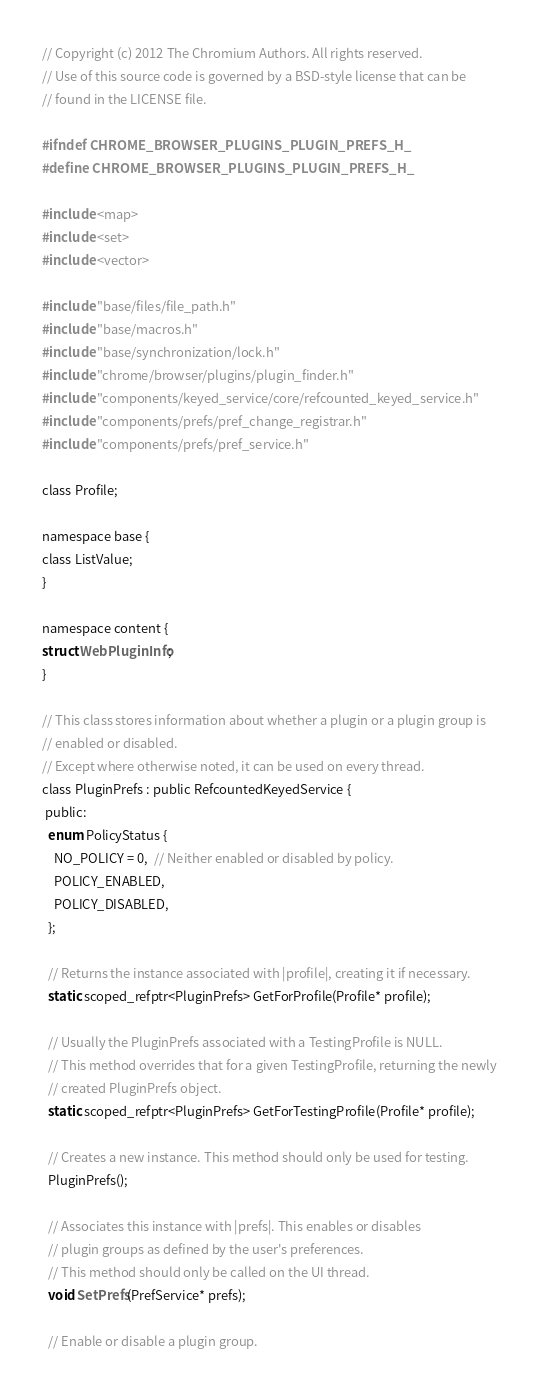<code> <loc_0><loc_0><loc_500><loc_500><_C_>// Copyright (c) 2012 The Chromium Authors. All rights reserved.
// Use of this source code is governed by a BSD-style license that can be
// found in the LICENSE file.

#ifndef CHROME_BROWSER_PLUGINS_PLUGIN_PREFS_H_
#define CHROME_BROWSER_PLUGINS_PLUGIN_PREFS_H_

#include <map>
#include <set>
#include <vector>

#include "base/files/file_path.h"
#include "base/macros.h"
#include "base/synchronization/lock.h"
#include "chrome/browser/plugins/plugin_finder.h"
#include "components/keyed_service/core/refcounted_keyed_service.h"
#include "components/prefs/pref_change_registrar.h"
#include "components/prefs/pref_service.h"

class Profile;

namespace base {
class ListValue;
}

namespace content {
struct WebPluginInfo;
}

// This class stores information about whether a plugin or a plugin group is
// enabled or disabled.
// Except where otherwise noted, it can be used on every thread.
class PluginPrefs : public RefcountedKeyedService {
 public:
  enum PolicyStatus {
    NO_POLICY = 0,  // Neither enabled or disabled by policy.
    POLICY_ENABLED,
    POLICY_DISABLED,
  };

  // Returns the instance associated with |profile|, creating it if necessary.
  static scoped_refptr<PluginPrefs> GetForProfile(Profile* profile);

  // Usually the PluginPrefs associated with a TestingProfile is NULL.
  // This method overrides that for a given TestingProfile, returning the newly
  // created PluginPrefs object.
  static scoped_refptr<PluginPrefs> GetForTestingProfile(Profile* profile);

  // Creates a new instance. This method should only be used for testing.
  PluginPrefs();

  // Associates this instance with |prefs|. This enables or disables
  // plugin groups as defined by the user's preferences.
  // This method should only be called on the UI thread.
  void SetPrefs(PrefService* prefs);

  // Enable or disable a plugin group.</code> 